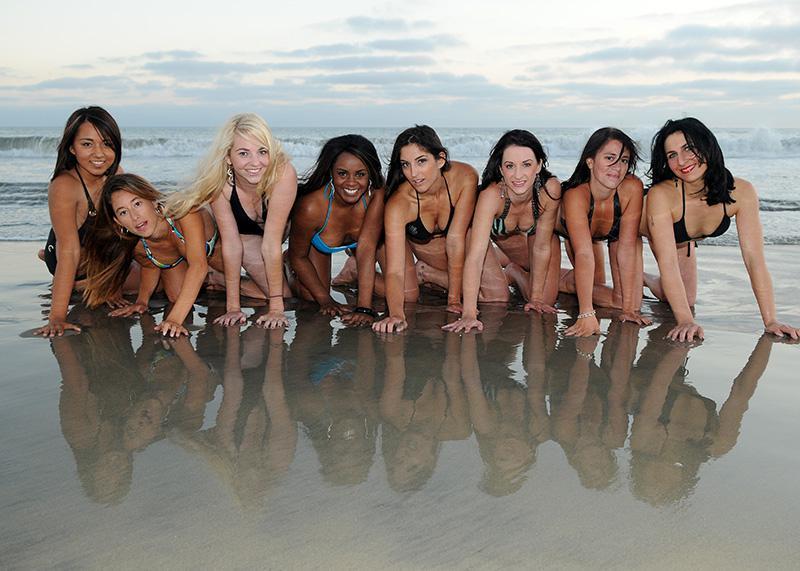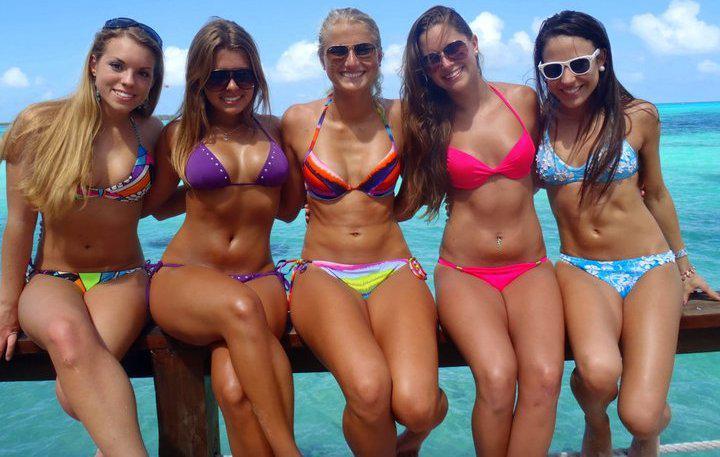The first image is the image on the left, the second image is the image on the right. Analyze the images presented: Is the assertion "One image contains at least 8 women." valid? Answer yes or no. Yes. The first image is the image on the left, the second image is the image on the right. Considering the images on both sides, is "All bikini models are standing, and no bikini models have their back and rear turned to the camera." valid? Answer yes or no. No. 